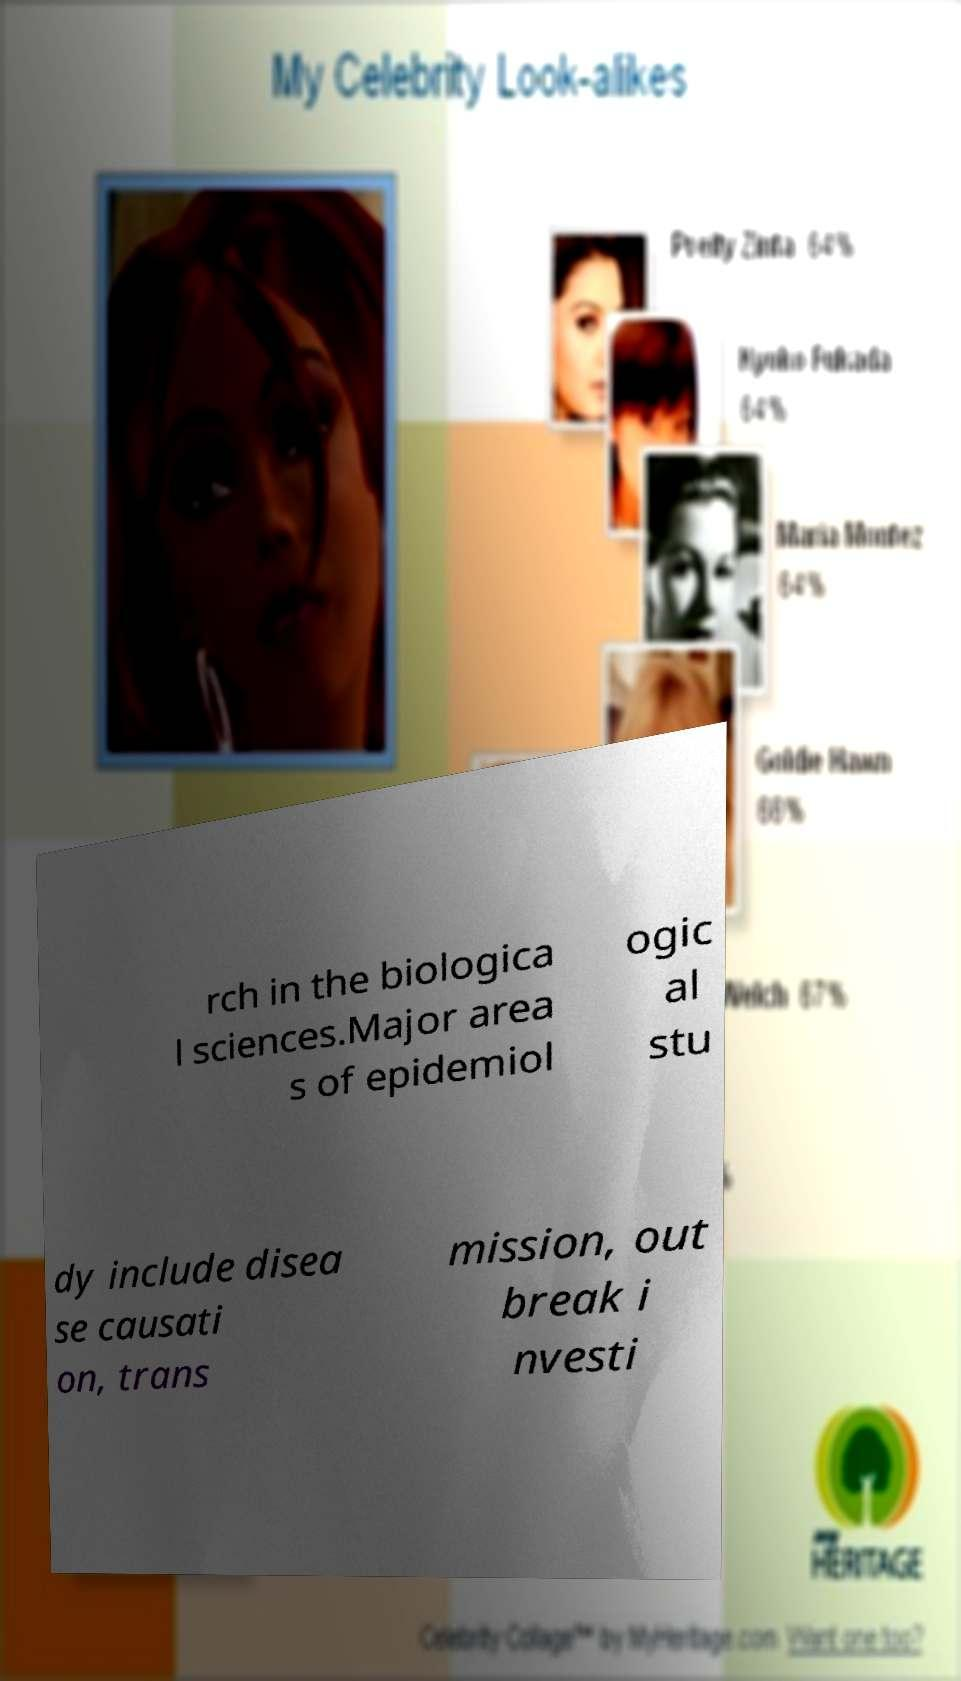I need the written content from this picture converted into text. Can you do that? rch in the biologica l sciences.Major area s of epidemiol ogic al stu dy include disea se causati on, trans mission, out break i nvesti 